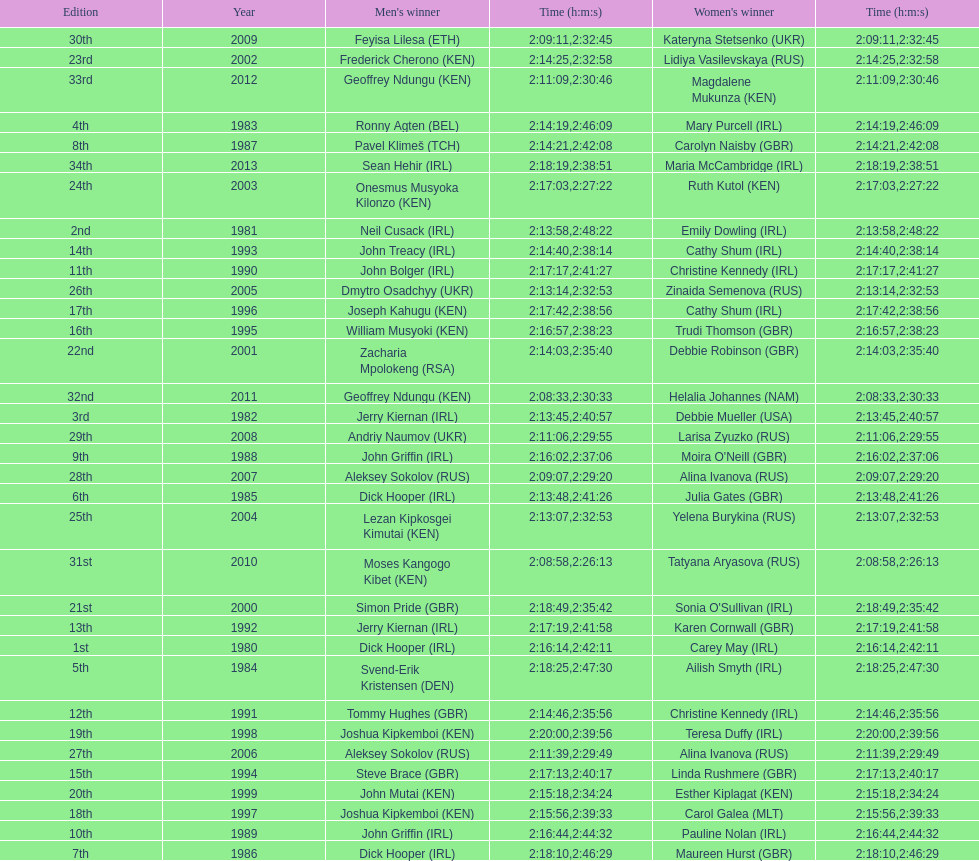Who won after joseph kipkemboi's winning streak ended? John Mutai (KEN). 